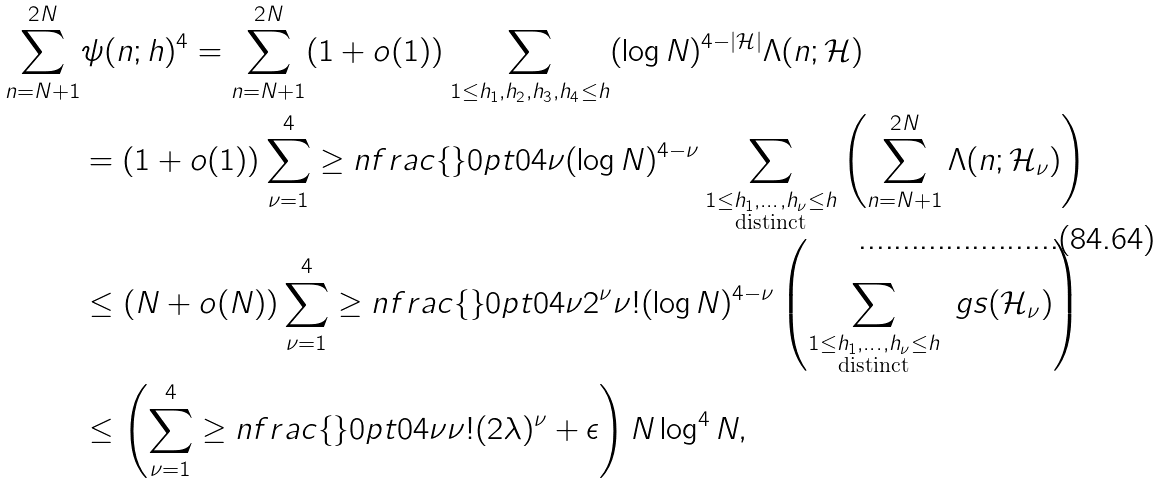<formula> <loc_0><loc_0><loc_500><loc_500>\sum _ { n = N + 1 } ^ { 2 N } & \psi ( n ; h ) ^ { 4 } = \sum _ { n = N + 1 } ^ { 2 N } ( 1 + o ( 1 ) ) \sum _ { 1 \leq h _ { 1 } , h _ { 2 } , h _ { 3 } , h _ { 4 } \leq h } ( \log N ) ^ { 4 - | \mathcal { H } | } \Lambda ( n ; \mathcal { H } ) \\ & = ( 1 + o ( 1 ) ) \sum _ { \nu = 1 } ^ { 4 } \geq n f r a c { \{ } { \} } { 0 p t } { 0 } { 4 } { \nu } ( \log N ) ^ { 4 - \nu } \sum _ { \substack { 1 \leq h _ { 1 } , \dots , h _ { \nu } \leq h \\ \text {distinct} } } \left ( \sum _ { n = N + 1 } ^ { 2 N } \Lambda ( n ; \mathcal { H } _ { \nu } ) \right ) \\ & \leq ( N + o ( N ) ) \sum _ { \nu = 1 } ^ { 4 } \geq n f r a c { \{ } { \} } { 0 p t } { 0 } { 4 } { \nu } 2 ^ { \nu } \nu ! ( \log N ) ^ { 4 - \nu } \left ( \sum _ { \substack { 1 \leq h _ { 1 } , \dots , h _ { \nu } \leq h \\ \text {distinct} } } \ g s ( \mathcal { H } _ { \nu } ) \right ) \\ & \leq \left ( \sum _ { \nu = 1 } ^ { 4 } \geq n f r a c { \{ } { \} } { 0 p t } { 0 } { 4 } { \nu } \nu ! ( 2 \lambda ) ^ { \nu } + \epsilon \right ) N \log ^ { 4 } N ,</formula> 